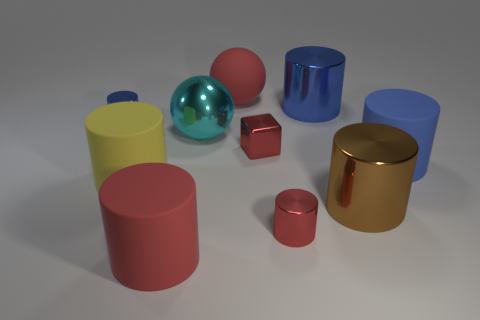Subtract all yellow cylinders. How many cylinders are left? 6 Subtract all yellow cylinders. How many cylinders are left? 6 Subtract all gray blocks. How many blue cylinders are left? 3 Add 3 tiny red blocks. How many tiny red blocks exist? 4 Subtract 0 blue blocks. How many objects are left? 10 Subtract all spheres. How many objects are left? 8 Subtract 2 cylinders. How many cylinders are left? 5 Subtract all gray balls. Subtract all purple cubes. How many balls are left? 2 Subtract all blue rubber things. Subtract all red things. How many objects are left? 5 Add 3 yellow objects. How many yellow objects are left? 4 